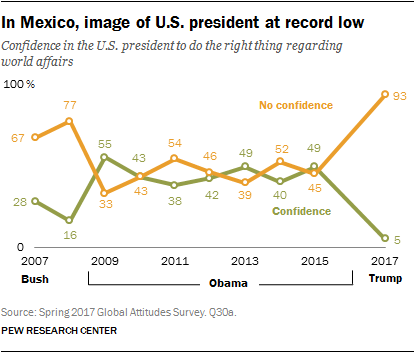List a handful of essential elements in this visual. In 2017, the difference between the No Confidence and Confidence values was 88. The Confidence value in the year 2017 was approximately 5. 